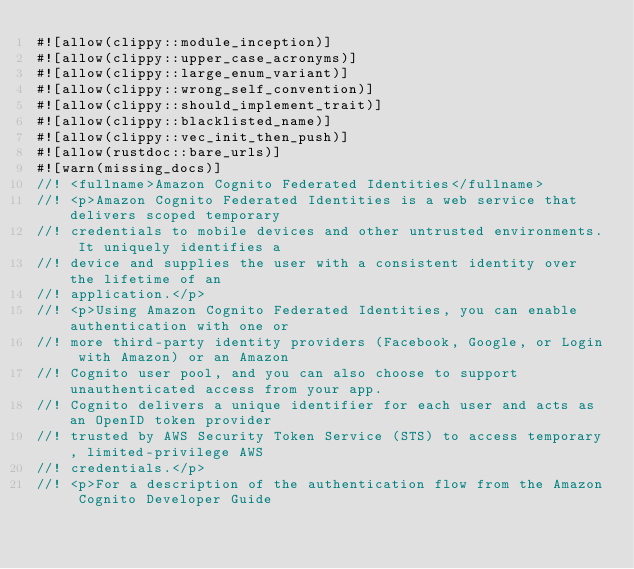<code> <loc_0><loc_0><loc_500><loc_500><_Rust_>#![allow(clippy::module_inception)]
#![allow(clippy::upper_case_acronyms)]
#![allow(clippy::large_enum_variant)]
#![allow(clippy::wrong_self_convention)]
#![allow(clippy::should_implement_trait)]
#![allow(clippy::blacklisted_name)]
#![allow(clippy::vec_init_then_push)]
#![allow(rustdoc::bare_urls)]
#![warn(missing_docs)]
//! <fullname>Amazon Cognito Federated Identities</fullname>
//! <p>Amazon Cognito Federated Identities is a web service that delivers scoped temporary
//! credentials to mobile devices and other untrusted environments. It uniquely identifies a
//! device and supplies the user with a consistent identity over the lifetime of an
//! application.</p>
//! <p>Using Amazon Cognito Federated Identities, you can enable authentication with one or
//! more third-party identity providers (Facebook, Google, or Login with Amazon) or an Amazon
//! Cognito user pool, and you can also choose to support unauthenticated access from your app.
//! Cognito delivers a unique identifier for each user and acts as an OpenID token provider
//! trusted by AWS Security Token Service (STS) to access temporary, limited-privilege AWS
//! credentials.</p>
//! <p>For a description of the authentication flow from the Amazon Cognito Developer Guide</code> 